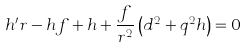Convert formula to latex. <formula><loc_0><loc_0><loc_500><loc_500>h ^ { \prime } r - h f + h + \frac { f } { r ^ { 2 } } \left ( d ^ { 2 } + q ^ { 2 } h \right ) = 0</formula> 